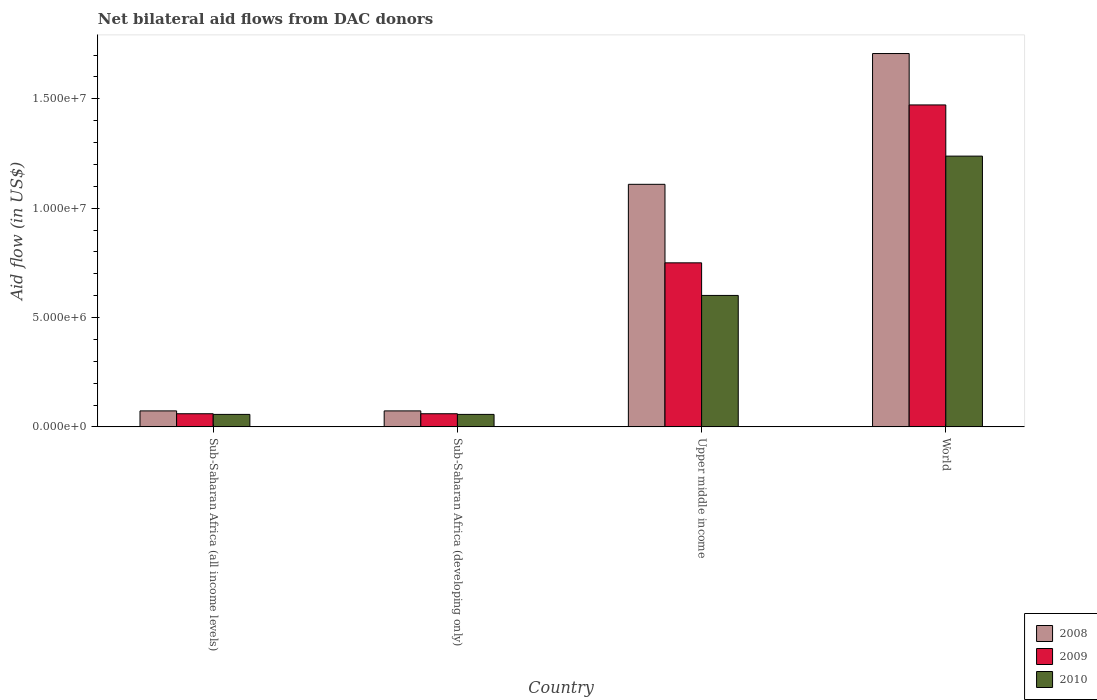How many different coloured bars are there?
Your answer should be very brief. 3. Are the number of bars per tick equal to the number of legend labels?
Provide a succinct answer. Yes. Are the number of bars on each tick of the X-axis equal?
Your answer should be compact. Yes. How many bars are there on the 3rd tick from the right?
Your answer should be compact. 3. What is the label of the 3rd group of bars from the left?
Provide a short and direct response. Upper middle income. In how many cases, is the number of bars for a given country not equal to the number of legend labels?
Give a very brief answer. 0. What is the net bilateral aid flow in 2009 in Sub-Saharan Africa (all income levels)?
Make the answer very short. 6.00e+05. Across all countries, what is the maximum net bilateral aid flow in 2008?
Provide a short and direct response. 1.71e+07. In which country was the net bilateral aid flow in 2008 maximum?
Offer a terse response. World. In which country was the net bilateral aid flow in 2010 minimum?
Your answer should be very brief. Sub-Saharan Africa (all income levels). What is the total net bilateral aid flow in 2008 in the graph?
Ensure brevity in your answer.  2.96e+07. What is the difference between the net bilateral aid flow in 2008 in Sub-Saharan Africa (developing only) and that in World?
Make the answer very short. -1.63e+07. What is the difference between the net bilateral aid flow in 2009 in World and the net bilateral aid flow in 2010 in Upper middle income?
Keep it short and to the point. 8.71e+06. What is the average net bilateral aid flow in 2009 per country?
Ensure brevity in your answer.  5.86e+06. What is the difference between the net bilateral aid flow of/in 2009 and net bilateral aid flow of/in 2010 in World?
Ensure brevity in your answer.  2.34e+06. In how many countries, is the net bilateral aid flow in 2010 greater than 3000000 US$?
Keep it short and to the point. 2. What is the difference between the highest and the second highest net bilateral aid flow in 2008?
Your answer should be very brief. 5.98e+06. What is the difference between the highest and the lowest net bilateral aid flow in 2008?
Your answer should be compact. 1.63e+07. Is the sum of the net bilateral aid flow in 2009 in Sub-Saharan Africa (all income levels) and World greater than the maximum net bilateral aid flow in 2010 across all countries?
Your answer should be compact. Yes. What does the 3rd bar from the left in Sub-Saharan Africa (developing only) represents?
Keep it short and to the point. 2010. Are the values on the major ticks of Y-axis written in scientific E-notation?
Keep it short and to the point. Yes. Does the graph contain grids?
Provide a succinct answer. No. How are the legend labels stacked?
Offer a terse response. Vertical. What is the title of the graph?
Make the answer very short. Net bilateral aid flows from DAC donors. What is the label or title of the X-axis?
Keep it short and to the point. Country. What is the label or title of the Y-axis?
Give a very brief answer. Aid flow (in US$). What is the Aid flow (in US$) in 2008 in Sub-Saharan Africa (all income levels)?
Keep it short and to the point. 7.30e+05. What is the Aid flow (in US$) in 2009 in Sub-Saharan Africa (all income levels)?
Your answer should be compact. 6.00e+05. What is the Aid flow (in US$) of 2010 in Sub-Saharan Africa (all income levels)?
Your answer should be compact. 5.70e+05. What is the Aid flow (in US$) in 2008 in Sub-Saharan Africa (developing only)?
Keep it short and to the point. 7.30e+05. What is the Aid flow (in US$) in 2009 in Sub-Saharan Africa (developing only)?
Your answer should be very brief. 6.00e+05. What is the Aid flow (in US$) in 2010 in Sub-Saharan Africa (developing only)?
Keep it short and to the point. 5.70e+05. What is the Aid flow (in US$) of 2008 in Upper middle income?
Provide a succinct answer. 1.11e+07. What is the Aid flow (in US$) of 2009 in Upper middle income?
Make the answer very short. 7.50e+06. What is the Aid flow (in US$) of 2010 in Upper middle income?
Give a very brief answer. 6.01e+06. What is the Aid flow (in US$) in 2008 in World?
Keep it short and to the point. 1.71e+07. What is the Aid flow (in US$) of 2009 in World?
Your response must be concise. 1.47e+07. What is the Aid flow (in US$) of 2010 in World?
Make the answer very short. 1.24e+07. Across all countries, what is the maximum Aid flow (in US$) in 2008?
Make the answer very short. 1.71e+07. Across all countries, what is the maximum Aid flow (in US$) of 2009?
Your answer should be compact. 1.47e+07. Across all countries, what is the maximum Aid flow (in US$) of 2010?
Ensure brevity in your answer.  1.24e+07. Across all countries, what is the minimum Aid flow (in US$) in 2008?
Ensure brevity in your answer.  7.30e+05. Across all countries, what is the minimum Aid flow (in US$) in 2009?
Make the answer very short. 6.00e+05. Across all countries, what is the minimum Aid flow (in US$) of 2010?
Offer a very short reply. 5.70e+05. What is the total Aid flow (in US$) in 2008 in the graph?
Make the answer very short. 2.96e+07. What is the total Aid flow (in US$) of 2009 in the graph?
Your answer should be very brief. 2.34e+07. What is the total Aid flow (in US$) of 2010 in the graph?
Offer a very short reply. 1.95e+07. What is the difference between the Aid flow (in US$) in 2008 in Sub-Saharan Africa (all income levels) and that in Upper middle income?
Your answer should be compact. -1.04e+07. What is the difference between the Aid flow (in US$) of 2009 in Sub-Saharan Africa (all income levels) and that in Upper middle income?
Your response must be concise. -6.90e+06. What is the difference between the Aid flow (in US$) of 2010 in Sub-Saharan Africa (all income levels) and that in Upper middle income?
Your answer should be compact. -5.44e+06. What is the difference between the Aid flow (in US$) of 2008 in Sub-Saharan Africa (all income levels) and that in World?
Offer a terse response. -1.63e+07. What is the difference between the Aid flow (in US$) in 2009 in Sub-Saharan Africa (all income levels) and that in World?
Give a very brief answer. -1.41e+07. What is the difference between the Aid flow (in US$) of 2010 in Sub-Saharan Africa (all income levels) and that in World?
Provide a succinct answer. -1.18e+07. What is the difference between the Aid flow (in US$) in 2008 in Sub-Saharan Africa (developing only) and that in Upper middle income?
Ensure brevity in your answer.  -1.04e+07. What is the difference between the Aid flow (in US$) in 2009 in Sub-Saharan Africa (developing only) and that in Upper middle income?
Offer a terse response. -6.90e+06. What is the difference between the Aid flow (in US$) in 2010 in Sub-Saharan Africa (developing only) and that in Upper middle income?
Provide a short and direct response. -5.44e+06. What is the difference between the Aid flow (in US$) of 2008 in Sub-Saharan Africa (developing only) and that in World?
Offer a very short reply. -1.63e+07. What is the difference between the Aid flow (in US$) of 2009 in Sub-Saharan Africa (developing only) and that in World?
Your response must be concise. -1.41e+07. What is the difference between the Aid flow (in US$) of 2010 in Sub-Saharan Africa (developing only) and that in World?
Give a very brief answer. -1.18e+07. What is the difference between the Aid flow (in US$) in 2008 in Upper middle income and that in World?
Make the answer very short. -5.98e+06. What is the difference between the Aid flow (in US$) in 2009 in Upper middle income and that in World?
Provide a succinct answer. -7.22e+06. What is the difference between the Aid flow (in US$) of 2010 in Upper middle income and that in World?
Offer a very short reply. -6.37e+06. What is the difference between the Aid flow (in US$) of 2008 in Sub-Saharan Africa (all income levels) and the Aid flow (in US$) of 2009 in Sub-Saharan Africa (developing only)?
Your response must be concise. 1.30e+05. What is the difference between the Aid flow (in US$) in 2008 in Sub-Saharan Africa (all income levels) and the Aid flow (in US$) in 2010 in Sub-Saharan Africa (developing only)?
Provide a short and direct response. 1.60e+05. What is the difference between the Aid flow (in US$) of 2008 in Sub-Saharan Africa (all income levels) and the Aid flow (in US$) of 2009 in Upper middle income?
Your response must be concise. -6.77e+06. What is the difference between the Aid flow (in US$) in 2008 in Sub-Saharan Africa (all income levels) and the Aid flow (in US$) in 2010 in Upper middle income?
Ensure brevity in your answer.  -5.28e+06. What is the difference between the Aid flow (in US$) in 2009 in Sub-Saharan Africa (all income levels) and the Aid flow (in US$) in 2010 in Upper middle income?
Make the answer very short. -5.41e+06. What is the difference between the Aid flow (in US$) of 2008 in Sub-Saharan Africa (all income levels) and the Aid flow (in US$) of 2009 in World?
Your answer should be compact. -1.40e+07. What is the difference between the Aid flow (in US$) of 2008 in Sub-Saharan Africa (all income levels) and the Aid flow (in US$) of 2010 in World?
Offer a terse response. -1.16e+07. What is the difference between the Aid flow (in US$) in 2009 in Sub-Saharan Africa (all income levels) and the Aid flow (in US$) in 2010 in World?
Your response must be concise. -1.18e+07. What is the difference between the Aid flow (in US$) in 2008 in Sub-Saharan Africa (developing only) and the Aid flow (in US$) in 2009 in Upper middle income?
Ensure brevity in your answer.  -6.77e+06. What is the difference between the Aid flow (in US$) of 2008 in Sub-Saharan Africa (developing only) and the Aid flow (in US$) of 2010 in Upper middle income?
Your answer should be very brief. -5.28e+06. What is the difference between the Aid flow (in US$) in 2009 in Sub-Saharan Africa (developing only) and the Aid flow (in US$) in 2010 in Upper middle income?
Ensure brevity in your answer.  -5.41e+06. What is the difference between the Aid flow (in US$) in 2008 in Sub-Saharan Africa (developing only) and the Aid flow (in US$) in 2009 in World?
Your answer should be very brief. -1.40e+07. What is the difference between the Aid flow (in US$) of 2008 in Sub-Saharan Africa (developing only) and the Aid flow (in US$) of 2010 in World?
Your response must be concise. -1.16e+07. What is the difference between the Aid flow (in US$) in 2009 in Sub-Saharan Africa (developing only) and the Aid flow (in US$) in 2010 in World?
Offer a terse response. -1.18e+07. What is the difference between the Aid flow (in US$) of 2008 in Upper middle income and the Aid flow (in US$) of 2009 in World?
Your response must be concise. -3.63e+06. What is the difference between the Aid flow (in US$) of 2008 in Upper middle income and the Aid flow (in US$) of 2010 in World?
Provide a succinct answer. -1.29e+06. What is the difference between the Aid flow (in US$) of 2009 in Upper middle income and the Aid flow (in US$) of 2010 in World?
Your answer should be very brief. -4.88e+06. What is the average Aid flow (in US$) of 2008 per country?
Your answer should be compact. 7.40e+06. What is the average Aid flow (in US$) of 2009 per country?
Your answer should be very brief. 5.86e+06. What is the average Aid flow (in US$) in 2010 per country?
Your answer should be compact. 4.88e+06. What is the difference between the Aid flow (in US$) of 2008 and Aid flow (in US$) of 2009 in Sub-Saharan Africa (all income levels)?
Give a very brief answer. 1.30e+05. What is the difference between the Aid flow (in US$) of 2008 and Aid flow (in US$) of 2010 in Sub-Saharan Africa (all income levels)?
Provide a succinct answer. 1.60e+05. What is the difference between the Aid flow (in US$) in 2009 and Aid flow (in US$) in 2010 in Sub-Saharan Africa (all income levels)?
Provide a short and direct response. 3.00e+04. What is the difference between the Aid flow (in US$) of 2008 and Aid flow (in US$) of 2009 in Sub-Saharan Africa (developing only)?
Give a very brief answer. 1.30e+05. What is the difference between the Aid flow (in US$) of 2008 and Aid flow (in US$) of 2010 in Sub-Saharan Africa (developing only)?
Provide a succinct answer. 1.60e+05. What is the difference between the Aid flow (in US$) of 2008 and Aid flow (in US$) of 2009 in Upper middle income?
Provide a short and direct response. 3.59e+06. What is the difference between the Aid flow (in US$) of 2008 and Aid flow (in US$) of 2010 in Upper middle income?
Provide a short and direct response. 5.08e+06. What is the difference between the Aid flow (in US$) of 2009 and Aid flow (in US$) of 2010 in Upper middle income?
Keep it short and to the point. 1.49e+06. What is the difference between the Aid flow (in US$) in 2008 and Aid flow (in US$) in 2009 in World?
Give a very brief answer. 2.35e+06. What is the difference between the Aid flow (in US$) in 2008 and Aid flow (in US$) in 2010 in World?
Ensure brevity in your answer.  4.69e+06. What is the difference between the Aid flow (in US$) of 2009 and Aid flow (in US$) of 2010 in World?
Keep it short and to the point. 2.34e+06. What is the ratio of the Aid flow (in US$) in 2009 in Sub-Saharan Africa (all income levels) to that in Sub-Saharan Africa (developing only)?
Give a very brief answer. 1. What is the ratio of the Aid flow (in US$) of 2010 in Sub-Saharan Africa (all income levels) to that in Sub-Saharan Africa (developing only)?
Your answer should be compact. 1. What is the ratio of the Aid flow (in US$) of 2008 in Sub-Saharan Africa (all income levels) to that in Upper middle income?
Make the answer very short. 0.07. What is the ratio of the Aid flow (in US$) in 2010 in Sub-Saharan Africa (all income levels) to that in Upper middle income?
Your answer should be compact. 0.09. What is the ratio of the Aid flow (in US$) in 2008 in Sub-Saharan Africa (all income levels) to that in World?
Ensure brevity in your answer.  0.04. What is the ratio of the Aid flow (in US$) of 2009 in Sub-Saharan Africa (all income levels) to that in World?
Your answer should be very brief. 0.04. What is the ratio of the Aid flow (in US$) in 2010 in Sub-Saharan Africa (all income levels) to that in World?
Provide a succinct answer. 0.05. What is the ratio of the Aid flow (in US$) in 2008 in Sub-Saharan Africa (developing only) to that in Upper middle income?
Ensure brevity in your answer.  0.07. What is the ratio of the Aid flow (in US$) in 2010 in Sub-Saharan Africa (developing only) to that in Upper middle income?
Give a very brief answer. 0.09. What is the ratio of the Aid flow (in US$) of 2008 in Sub-Saharan Africa (developing only) to that in World?
Give a very brief answer. 0.04. What is the ratio of the Aid flow (in US$) in 2009 in Sub-Saharan Africa (developing only) to that in World?
Your response must be concise. 0.04. What is the ratio of the Aid flow (in US$) of 2010 in Sub-Saharan Africa (developing only) to that in World?
Give a very brief answer. 0.05. What is the ratio of the Aid flow (in US$) of 2008 in Upper middle income to that in World?
Ensure brevity in your answer.  0.65. What is the ratio of the Aid flow (in US$) in 2009 in Upper middle income to that in World?
Your answer should be compact. 0.51. What is the ratio of the Aid flow (in US$) of 2010 in Upper middle income to that in World?
Make the answer very short. 0.49. What is the difference between the highest and the second highest Aid flow (in US$) in 2008?
Ensure brevity in your answer.  5.98e+06. What is the difference between the highest and the second highest Aid flow (in US$) in 2009?
Keep it short and to the point. 7.22e+06. What is the difference between the highest and the second highest Aid flow (in US$) of 2010?
Give a very brief answer. 6.37e+06. What is the difference between the highest and the lowest Aid flow (in US$) in 2008?
Provide a short and direct response. 1.63e+07. What is the difference between the highest and the lowest Aid flow (in US$) in 2009?
Keep it short and to the point. 1.41e+07. What is the difference between the highest and the lowest Aid flow (in US$) in 2010?
Give a very brief answer. 1.18e+07. 